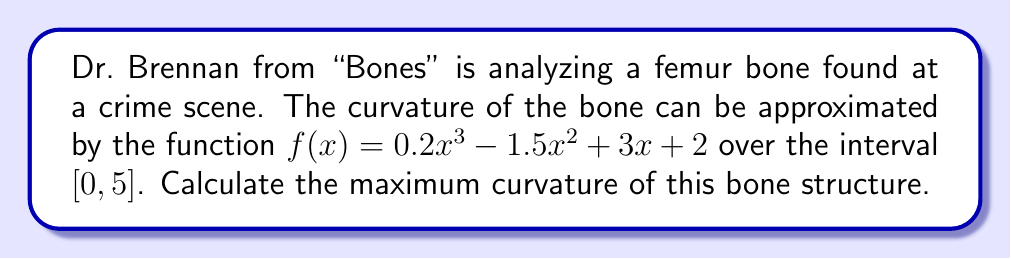What is the answer to this math problem? To find the maximum curvature, we'll follow these steps:

1) The curvature formula is given by:

   $$\kappa = \frac{|f''(x)|}{(1 + [f'(x)]^2)^{3/2}}$$

2) First, let's find $f'(x)$ and $f''(x)$:
   
   $f'(x) = 0.6x^2 - 3x + 3$
   $f''(x) = 1.2x - 3$

3) Substitute these into the curvature formula:

   $$\kappa = \frac{|1.2x - 3|}{(1 + [0.6x^2 - 3x + 3]^2)^{3/2}}$$

4) To find the maximum curvature, we need to find where $\frac{d\kappa}{dx} = 0$. However, this leads to a complex equation. Instead, we can plot $\kappa(x)$ over $[0, 5]$ and find its maximum value numerically.

5) Using a graphing calculator or computer software, we can determine that the maximum curvature occurs at approximately $x = 2.5$.

6) Evaluating $\kappa$ at $x = 2.5$:

   $$\kappa(2.5) = \frac{|1.2(2.5) - 3|}{(1 + [0.6(2.5)^2 - 3(2.5) + 3]^2)^{3/2}} \approx 0.3849$$

Therefore, the maximum curvature of the bone structure is approximately 0.3849.
Answer: 0.3849 